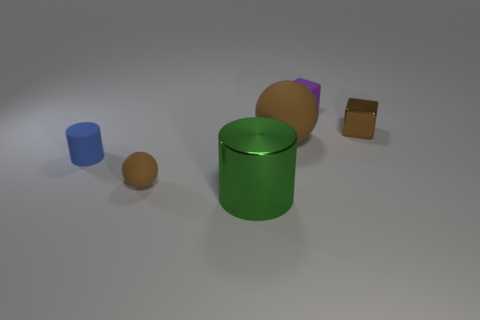What size is the cylinder on the left side of the tiny brown matte object?
Offer a terse response. Small. What number of brown metal objects are the same size as the blue cylinder?
Ensure brevity in your answer.  1. The object that is both on the left side of the large green object and right of the small blue object is made of what material?
Provide a short and direct response. Rubber. There is a purple block that is the same size as the blue matte object; what is its material?
Your answer should be very brief. Rubber. What size is the cube right of the tiny cube that is left of the small brown object right of the small rubber block?
Give a very brief answer. Small. There is a blue object that is made of the same material as the big sphere; what size is it?
Offer a very short reply. Small. There is a brown metallic object; is it the same size as the metal thing that is on the left side of the small purple matte block?
Keep it short and to the point. No. The small brown object on the left side of the small purple cube has what shape?
Offer a terse response. Sphere. Are there any large rubber balls that are on the left side of the metallic object that is on the right side of the small thing that is behind the small brown cube?
Keep it short and to the point. Yes. There is another object that is the same shape as the tiny brown shiny thing; what is its material?
Provide a succinct answer. Rubber. 